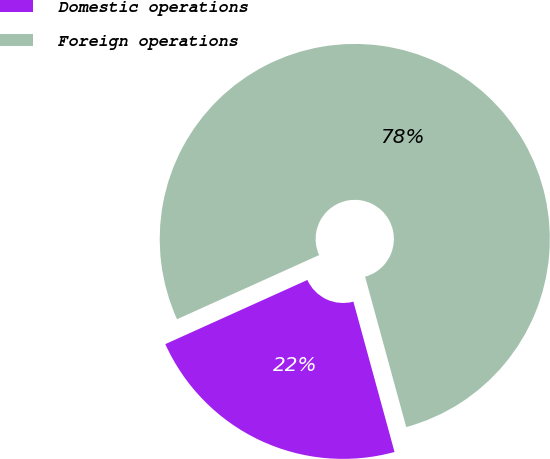Convert chart to OTSL. <chart><loc_0><loc_0><loc_500><loc_500><pie_chart><fcel>Domestic operations<fcel>Foreign operations<nl><fcel>22.5%<fcel>77.5%<nl></chart> 